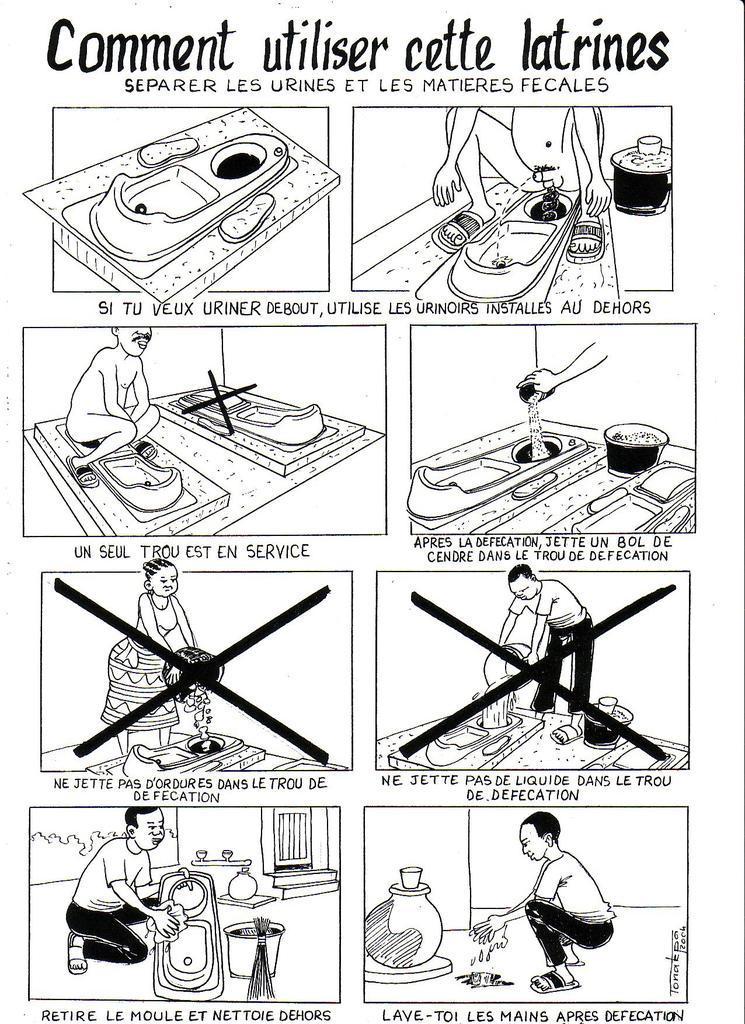What is featured on the poster in the image? There is writing on the poster, pictures of people, and toilet seats depicted on the poster. Can you describe the content of the writing on the poster? Unfortunately, the specific content of the writing cannot be determined from the image alone. What type of people are depicted on the poster? The images of people on the poster cannot be identified in detail from the image. What type of cushion is being used by the aunt in the image? There is no aunt or cushion present in the image. What type of advice does the father give to the child in the image? There is no father or child present in the image. 